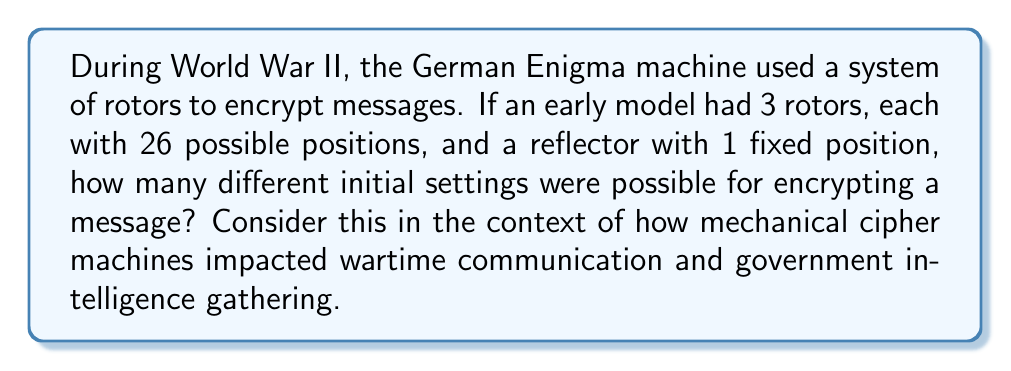Can you solve this math problem? To solve this problem, we need to consider the number of possible combinations for the rotor settings:

1. For the first rotor, we have 26 possible positions.
2. For the second rotor, we again have 26 possible positions.
3. For the third rotor, we also have 26 possible positions.
4. The reflector has only 1 fixed position, so it doesn't contribute to the number of combinations.

To calculate the total number of possible combinations, we multiply the number of possibilities for each component:

$$ \text{Total combinations} = 26 \times 26 \times 26 = 26^3 $$

Let's calculate this:

$$ 26^3 = 26 \times 26 \times 26 = 17,576 $$

This large number of possible initial settings made it challenging for enemies to decrypt messages without knowing the exact setup, highlighting the importance of mechanical cipher machines in secure wartime communication. The complexity of these machines also led to the development of more advanced code-breaking techniques and early computers, significantly impacting government intelligence gathering capabilities.
Answer: 17,576 